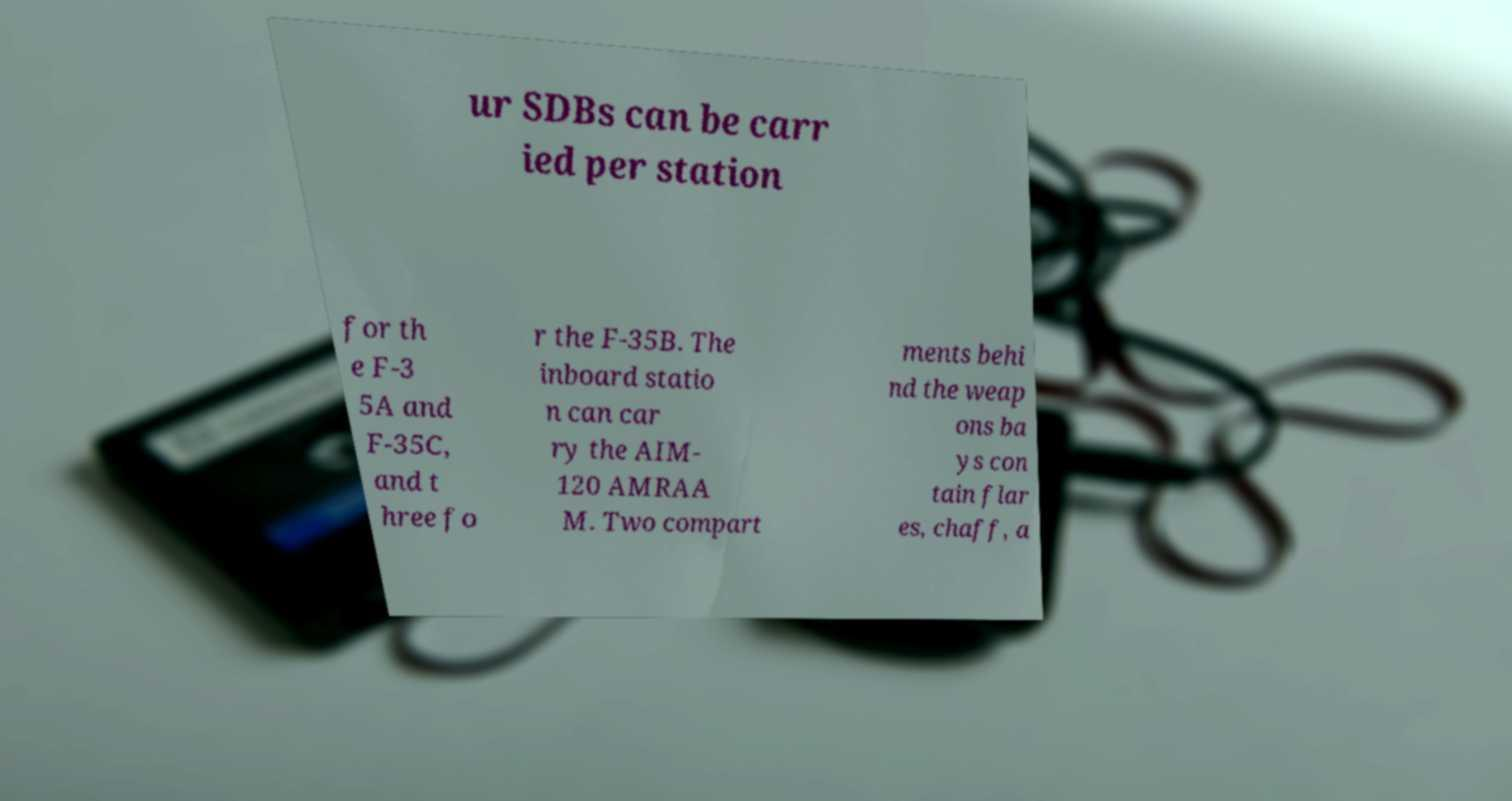Could you assist in decoding the text presented in this image and type it out clearly? ur SDBs can be carr ied per station for th e F-3 5A and F-35C, and t hree fo r the F-35B. The inboard statio n can car ry the AIM- 120 AMRAA M. Two compart ments behi nd the weap ons ba ys con tain flar es, chaff, a 